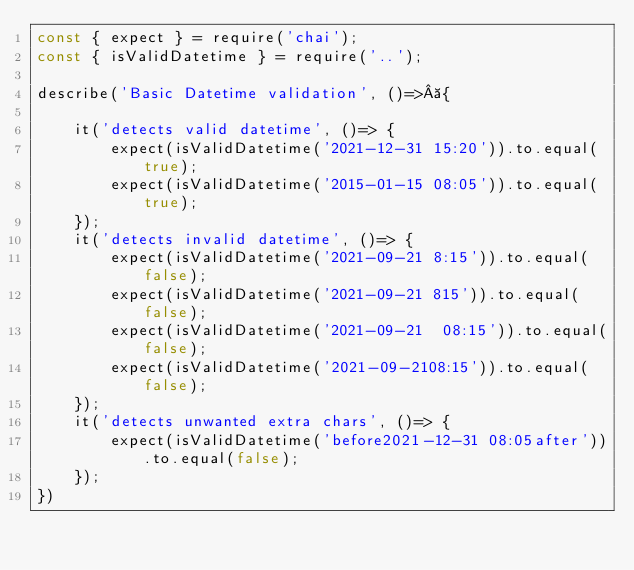<code> <loc_0><loc_0><loc_500><loc_500><_JavaScript_>const { expect } = require('chai');
const { isValidDatetime } = require('..');

describe('Basic Datetime validation', ()=> {

    it('detects valid datetime', ()=> {
        expect(isValidDatetime('2021-12-31 15:20')).to.equal(true);
        expect(isValidDatetime('2015-01-15 08:05')).to.equal(true);
    });
    it('detects invalid datetime', ()=> {
        expect(isValidDatetime('2021-09-21 8:15')).to.equal(false);
        expect(isValidDatetime('2021-09-21 815')).to.equal(false);
        expect(isValidDatetime('2021-09-21  08:15')).to.equal(false);
        expect(isValidDatetime('2021-09-2108:15')).to.equal(false);
    });
    it('detects unwanted extra chars', ()=> {
        expect(isValidDatetime('before2021-12-31 08:05after')).to.equal(false);
    });
})</code> 